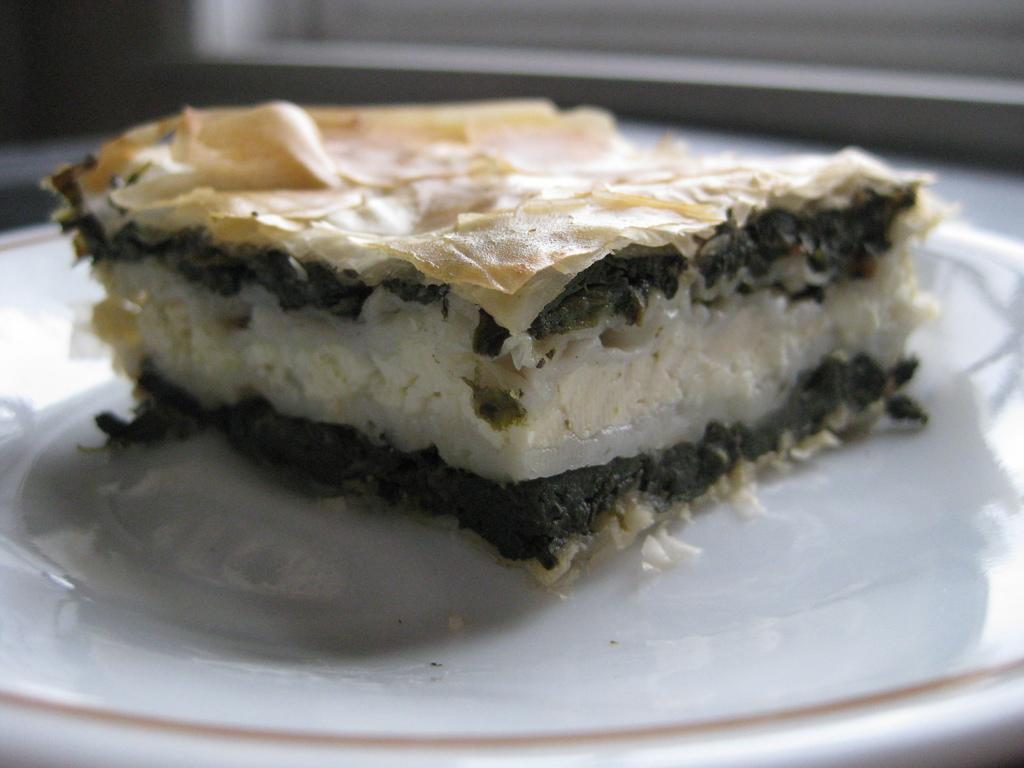How would you summarize this image in a sentence or two? In this image I can see a white colour plate and in it I can see food. I can see colour of the food is black, white and cream. I can also see this image is little bit blurry in the background. 